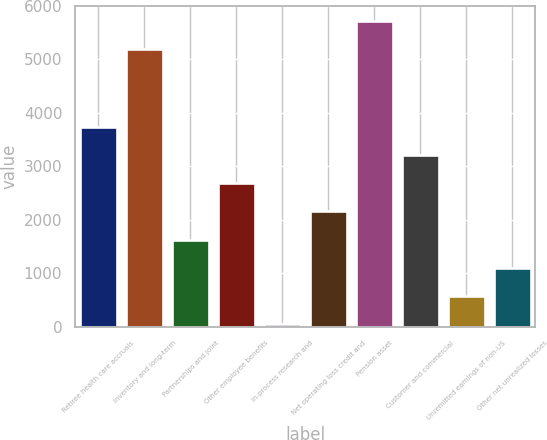Convert chart to OTSL. <chart><loc_0><loc_0><loc_500><loc_500><bar_chart><fcel>Retiree health care accruals<fcel>Inventory and long-term<fcel>Partnerships and joint<fcel>Other employee benefits<fcel>In-process research and<fcel>Net operating loss credit and<fcel>Pension asset<fcel>Customer and commercial<fcel>Unremitted earnings of non-US<fcel>Other net unrealized losses<nl><fcel>3735.8<fcel>5189<fcel>1630.2<fcel>2683<fcel>51<fcel>2156.6<fcel>5715.4<fcel>3209.4<fcel>577.4<fcel>1103.8<nl></chart> 